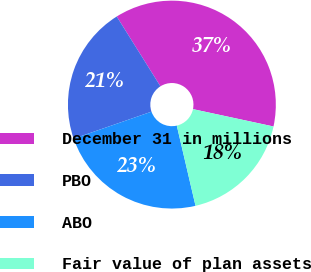<chart> <loc_0><loc_0><loc_500><loc_500><pie_chart><fcel>December 31 in millions<fcel>PBO<fcel>ABO<fcel>Fair value of plan assets<nl><fcel>37.28%<fcel>21.41%<fcel>23.34%<fcel>17.97%<nl></chart> 